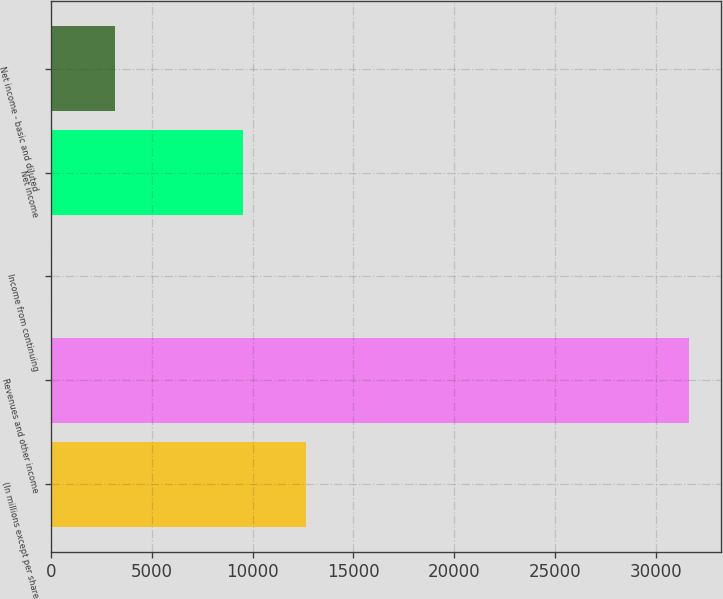<chart> <loc_0><loc_0><loc_500><loc_500><bar_chart><fcel>(In millions except per share<fcel>Revenues and other income<fcel>Income from continuing<fcel>Net income<fcel>Net income - basic and diluted<nl><fcel>12660.2<fcel>31648<fcel>1.63<fcel>9495.55<fcel>3166.27<nl></chart> 